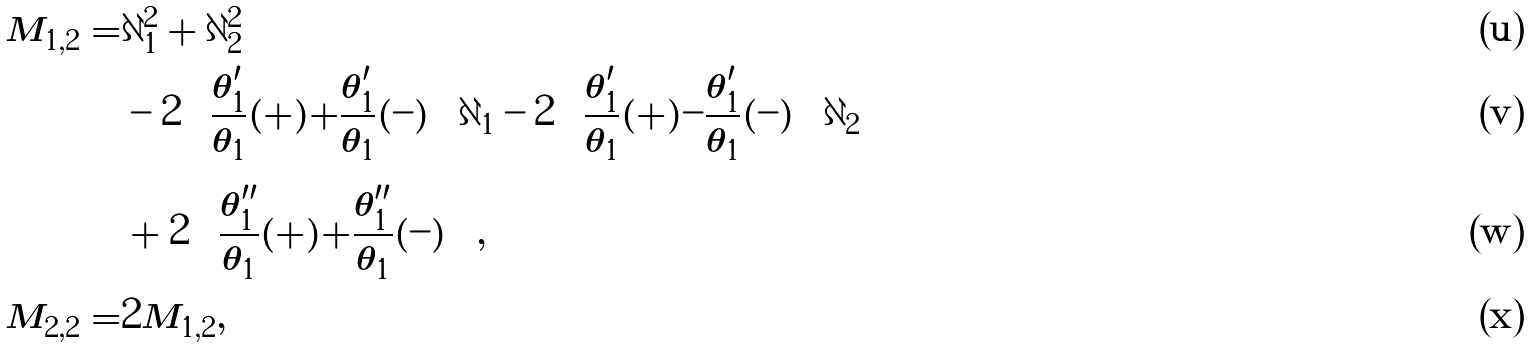Convert formula to latex. <formula><loc_0><loc_0><loc_500><loc_500>M _ { 1 , 2 } = & \partial _ { 1 } ^ { 2 } + \partial _ { 2 } ^ { 2 } \\ & - 2 \left ( \frac { \theta ^ { \prime } _ { 1 } } { \theta _ { 1 } } ( + ) + \frac { \theta ^ { \prime } _ { 1 } } { \theta _ { 1 } } ( - ) \right ) \partial _ { 1 } - 2 \left ( \frac { \theta ^ { \prime } _ { 1 } } { \theta _ { 1 } } ( + ) - \frac { \theta ^ { \prime } _ { 1 } } { \theta _ { 1 } } ( - ) \right ) \partial _ { 2 } \\ & + 2 \left ( \frac { \theta ^ { \prime \prime } _ { 1 } } { \theta _ { 1 } } ( + ) + \frac { \theta ^ { \prime \prime } _ { 1 } } { \theta _ { 1 } } ( - ) \right ) , \\ M _ { 2 , 2 } = & 2 M _ { 1 , 2 } ,</formula> 